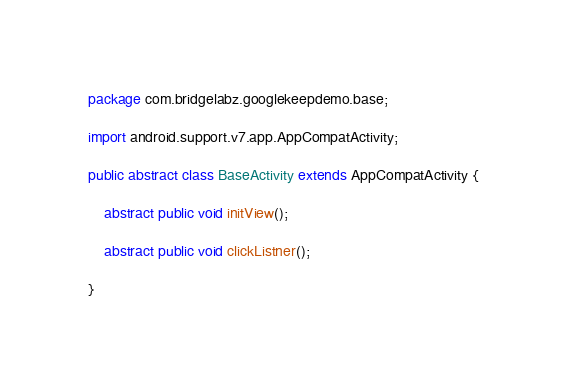Convert code to text. <code><loc_0><loc_0><loc_500><loc_500><_Java_>package com.bridgelabz.googlekeepdemo.base;

import android.support.v7.app.AppCompatActivity;

public abstract class BaseActivity extends AppCompatActivity {

    abstract public void initView();

    abstract public void clickListner();

}</code> 